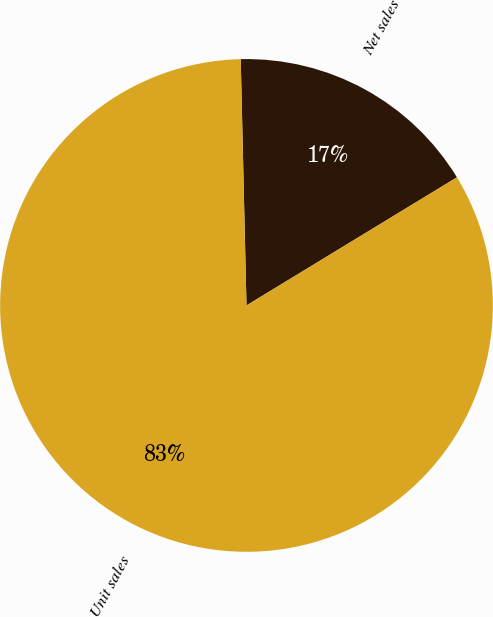<chart> <loc_0><loc_0><loc_500><loc_500><pie_chart><fcel>Net sales<fcel>Unit sales<nl><fcel>16.67%<fcel>83.33%<nl></chart> 